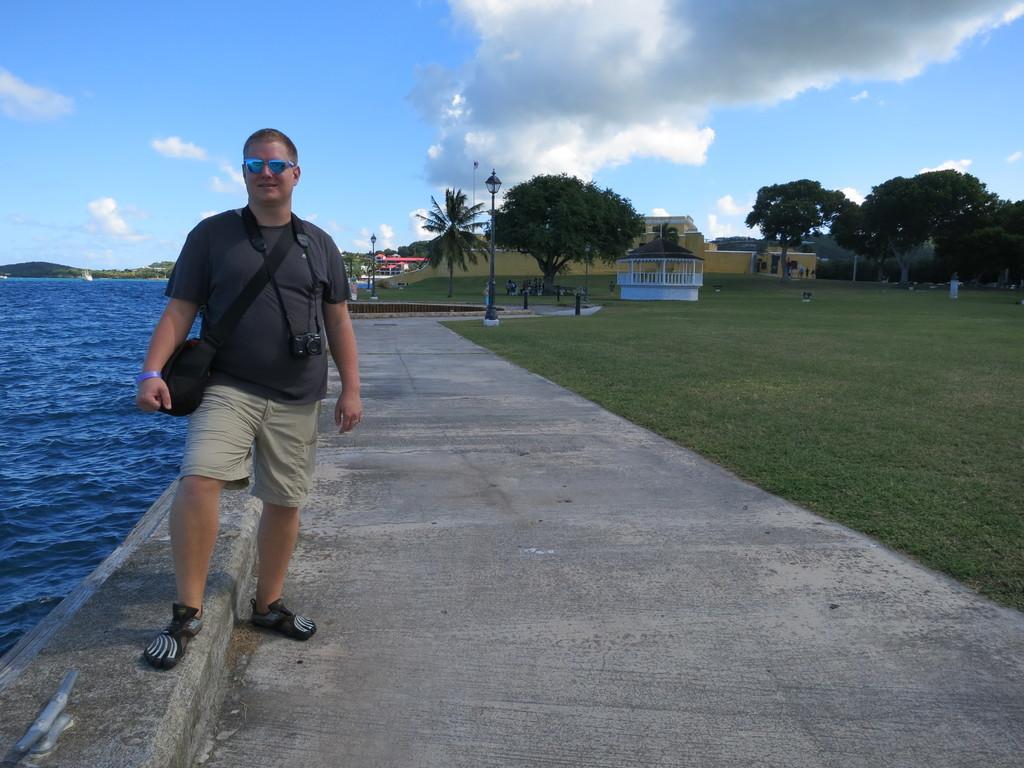Can you describe this image briefly? In this picture I can see buildings, trees and few lights and grass on the ground and man wore a bag and a camera and I can see a blue cloudy sky and water on the side. 